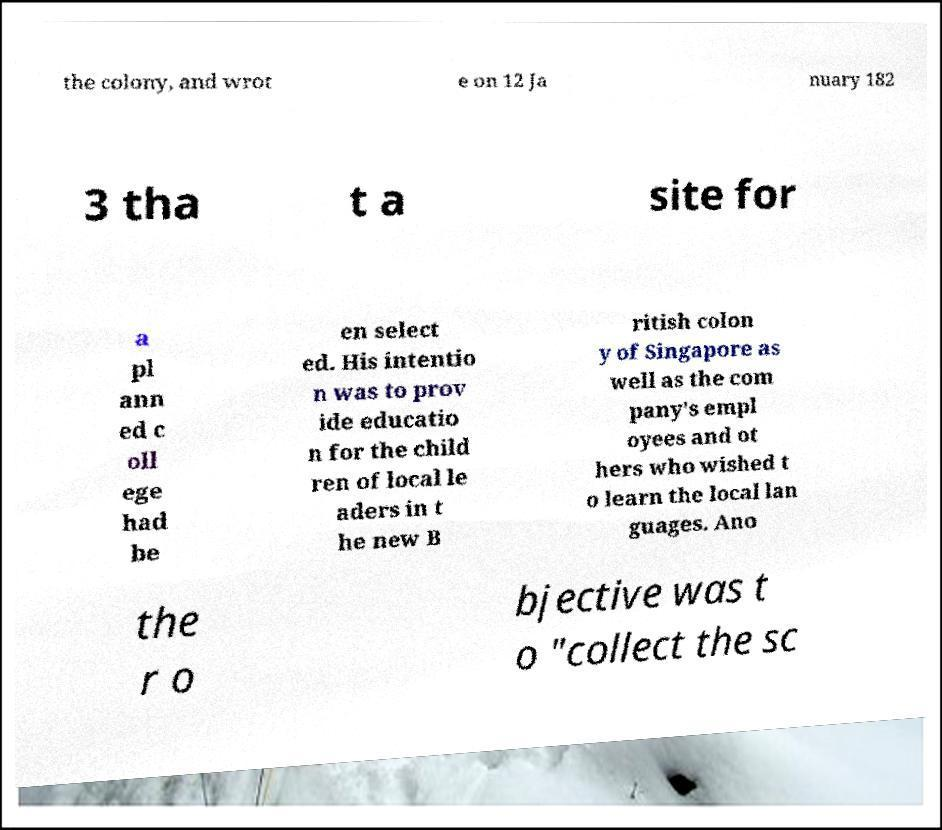I need the written content from this picture converted into text. Can you do that? the colony, and wrot e on 12 Ja nuary 182 3 tha t a site for a pl ann ed c oll ege had be en select ed. His intentio n was to prov ide educatio n for the child ren of local le aders in t he new B ritish colon y of Singapore as well as the com pany's empl oyees and ot hers who wished t o learn the local lan guages. Ano the r o bjective was t o "collect the sc 